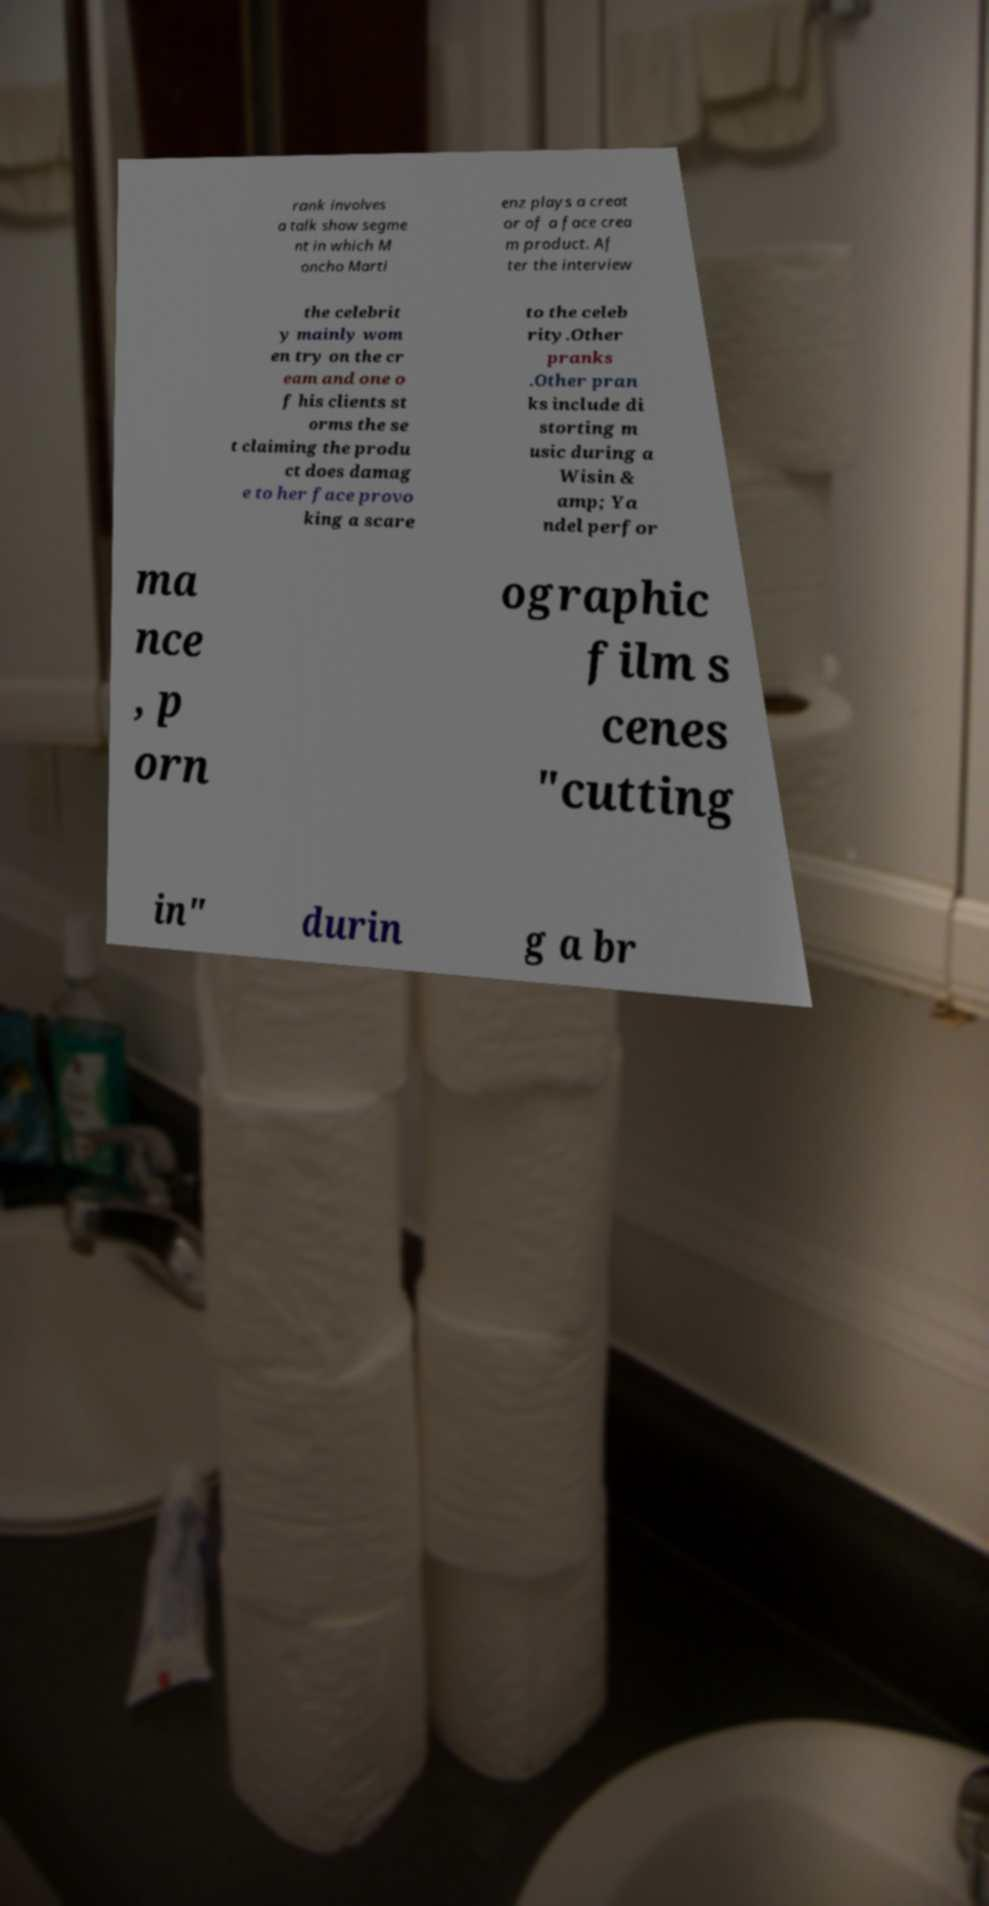There's text embedded in this image that I need extracted. Can you transcribe it verbatim? rank involves a talk show segme nt in which M oncho Marti enz plays a creat or of a face crea m product. Af ter the interview the celebrit y mainly wom en try on the cr eam and one o f his clients st orms the se t claiming the produ ct does damag e to her face provo king a scare to the celeb rity.Other pranks .Other pran ks include di storting m usic during a Wisin & amp; Ya ndel perfor ma nce , p orn ographic film s cenes "cutting in" durin g a br 